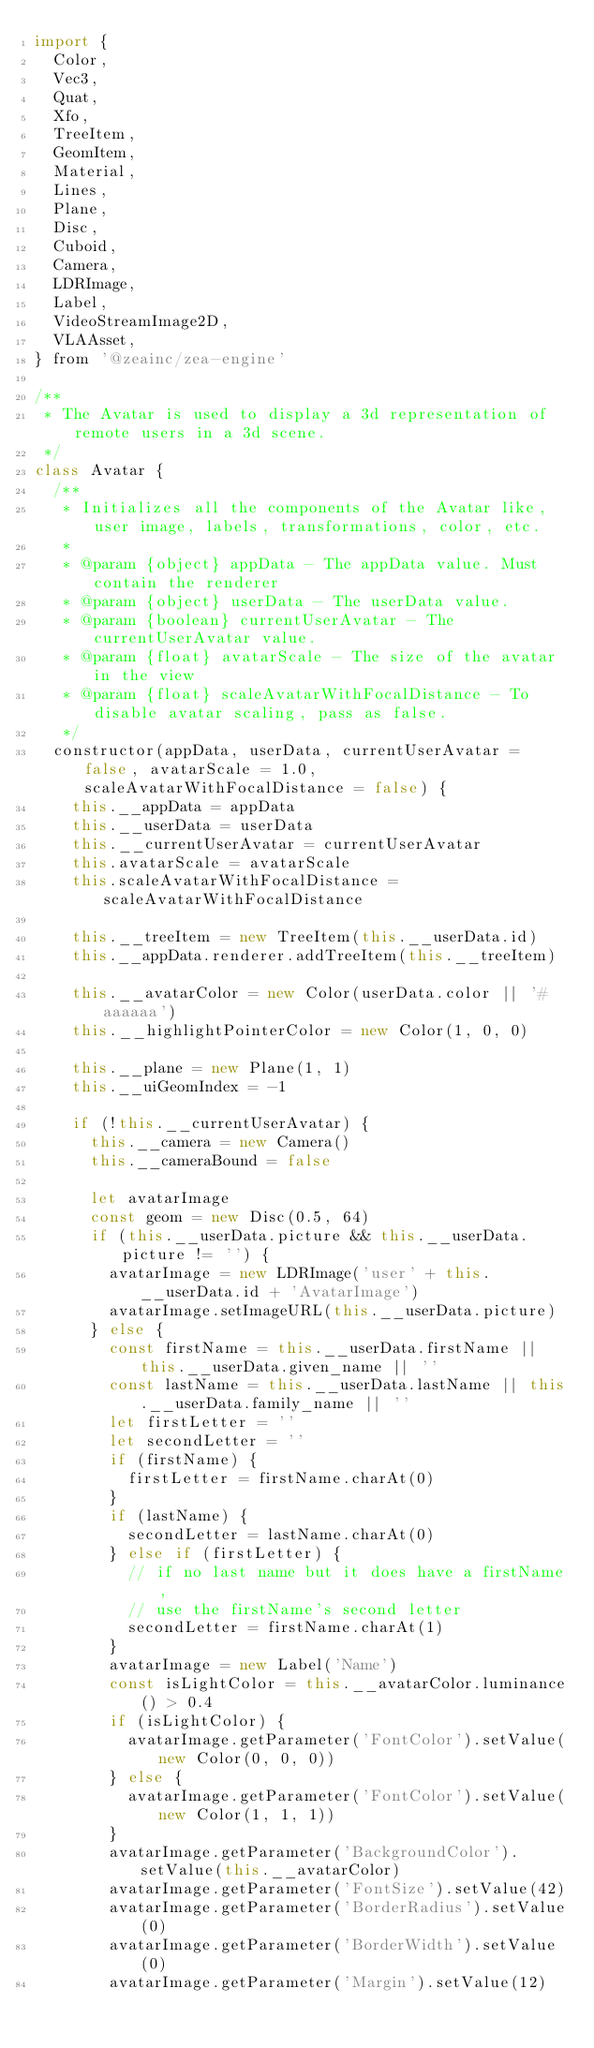<code> <loc_0><loc_0><loc_500><loc_500><_JavaScript_>import {
  Color,
  Vec3,
  Quat,
  Xfo,
  TreeItem,
  GeomItem,
  Material,
  Lines,
  Plane,
  Disc,
  Cuboid,
  Camera,
  LDRImage,
  Label,
  VideoStreamImage2D,
  VLAAsset,
} from '@zeainc/zea-engine'

/**
 * The Avatar is used to display a 3d representation of remote users in a 3d scene.
 */
class Avatar {
  /**
   * Initializes all the components of the Avatar like, user image, labels, transformations, color, etc.
   *
   * @param {object} appData - The appData value. Must contain the renderer
   * @param {object} userData - The userData value.
   * @param {boolean} currentUserAvatar - The currentUserAvatar value.
   * @param {float} avatarScale - The size of the avatar in the view
   * @param {float} scaleAvatarWithFocalDistance - To disable avatar scaling, pass as false.
   */
  constructor(appData, userData, currentUserAvatar = false, avatarScale = 1.0, scaleAvatarWithFocalDistance = false) {
    this.__appData = appData
    this.__userData = userData
    this.__currentUserAvatar = currentUserAvatar
    this.avatarScale = avatarScale
    this.scaleAvatarWithFocalDistance = scaleAvatarWithFocalDistance

    this.__treeItem = new TreeItem(this.__userData.id)
    this.__appData.renderer.addTreeItem(this.__treeItem)

    this.__avatarColor = new Color(userData.color || '#aaaaaa')
    this.__highlightPointerColor = new Color(1, 0, 0)

    this.__plane = new Plane(1, 1)
    this.__uiGeomIndex = -1

    if (!this.__currentUserAvatar) {
      this.__camera = new Camera()
      this.__cameraBound = false

      let avatarImage
      const geom = new Disc(0.5, 64)
      if (this.__userData.picture && this.__userData.picture != '') {
        avatarImage = new LDRImage('user' + this.__userData.id + 'AvatarImage')
        avatarImage.setImageURL(this.__userData.picture)
      } else {
        const firstName = this.__userData.firstName || this.__userData.given_name || ''
        const lastName = this.__userData.lastName || this.__userData.family_name || ''
        let firstLetter = ''
        let secondLetter = ''
        if (firstName) {
          firstLetter = firstName.charAt(0)
        }
        if (lastName) {
          secondLetter = lastName.charAt(0)
        } else if (firstLetter) {
          // if no last name but it does have a firstName,
          // use the firstName's second letter
          secondLetter = firstName.charAt(1)
        }
        avatarImage = new Label('Name')
        const isLightColor = this.__avatarColor.luminance() > 0.4
        if (isLightColor) {
          avatarImage.getParameter('FontColor').setValue(new Color(0, 0, 0))
        } else {
          avatarImage.getParameter('FontColor').setValue(new Color(1, 1, 1))
        }
        avatarImage.getParameter('BackgroundColor').setValue(this.__avatarColor)
        avatarImage.getParameter('FontSize').setValue(42)
        avatarImage.getParameter('BorderRadius').setValue(0)
        avatarImage.getParameter('BorderWidth').setValue(0)
        avatarImage.getParameter('Margin').setValue(12)</code> 